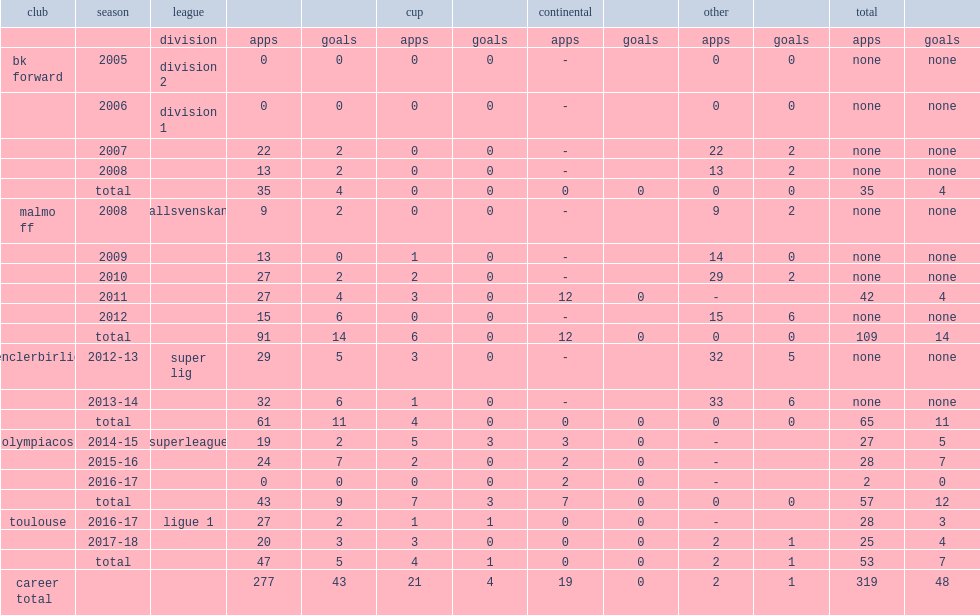Which club did jimmy durmaz play for in 2009? Malmo ff. 